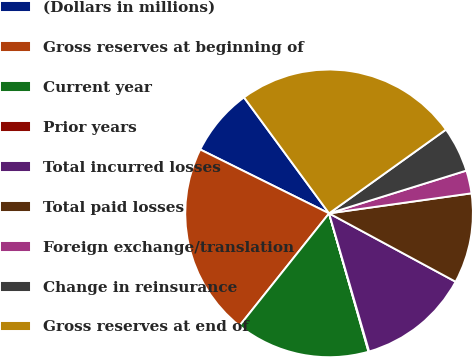Convert chart. <chart><loc_0><loc_0><loc_500><loc_500><pie_chart><fcel>(Dollars in millions)<fcel>Gross reserves at beginning of<fcel>Current year<fcel>Prior years<fcel>Total incurred losses<fcel>Total paid losses<fcel>Foreign exchange/translation<fcel>Change in reinsurance<fcel>Gross reserves at end of<nl><fcel>7.6%<fcel>21.61%<fcel>15.13%<fcel>0.07%<fcel>12.62%<fcel>10.11%<fcel>2.58%<fcel>5.09%<fcel>25.17%<nl></chart> 